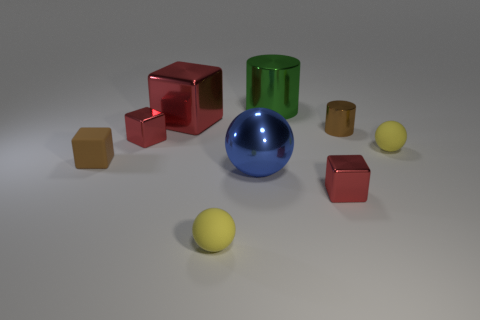Subtract all big balls. How many balls are left? 2 Subtract all blue spheres. How many spheres are left? 2 Subtract all spheres. How many objects are left? 6 Add 2 large blue metal balls. How many large blue metal balls are left? 3 Add 5 matte objects. How many matte objects exist? 8 Add 1 metallic blocks. How many objects exist? 10 Subtract 0 purple balls. How many objects are left? 9 Subtract 1 spheres. How many spheres are left? 2 Subtract all purple blocks. Subtract all brown cylinders. How many blocks are left? 4 Subtract all gray cubes. How many yellow spheres are left? 2 